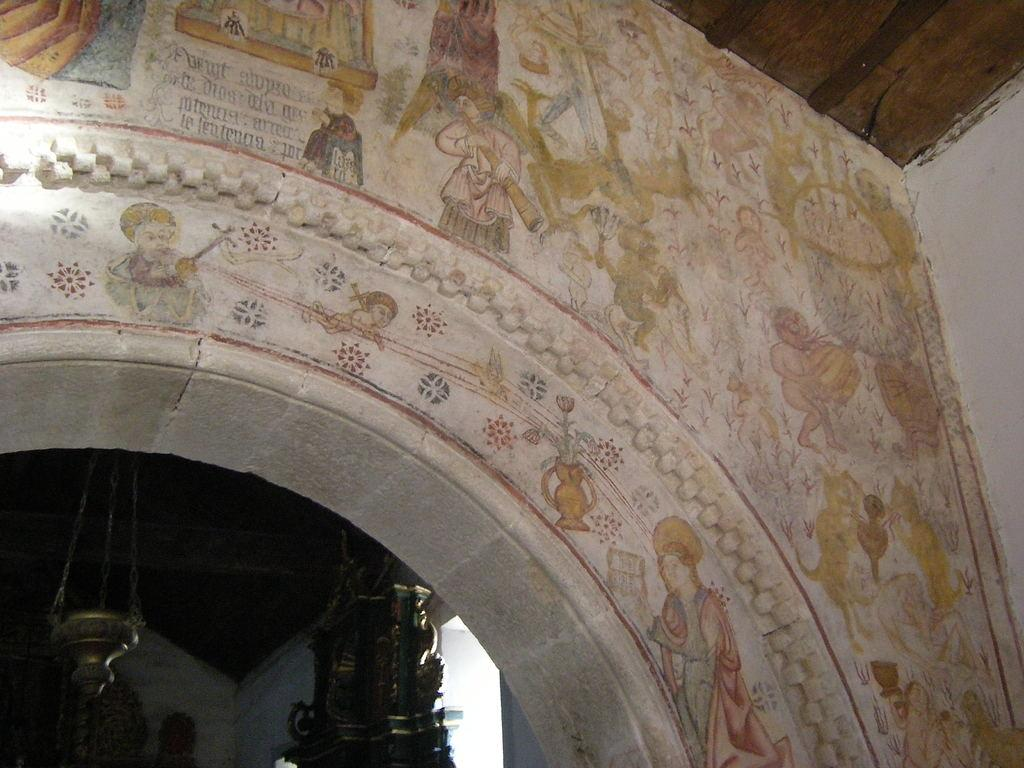What is present on the wall in the image? There are paintings on the wall in the image. Can you describe the background of the image? There are objects visible in the background of the image. What type of bean is being used as a prop in the image? There is no bean present in the image. What is the reaction of the people in the image to the paintings on the wall? There are no people visible in the image, so their reactions cannot be determined. 